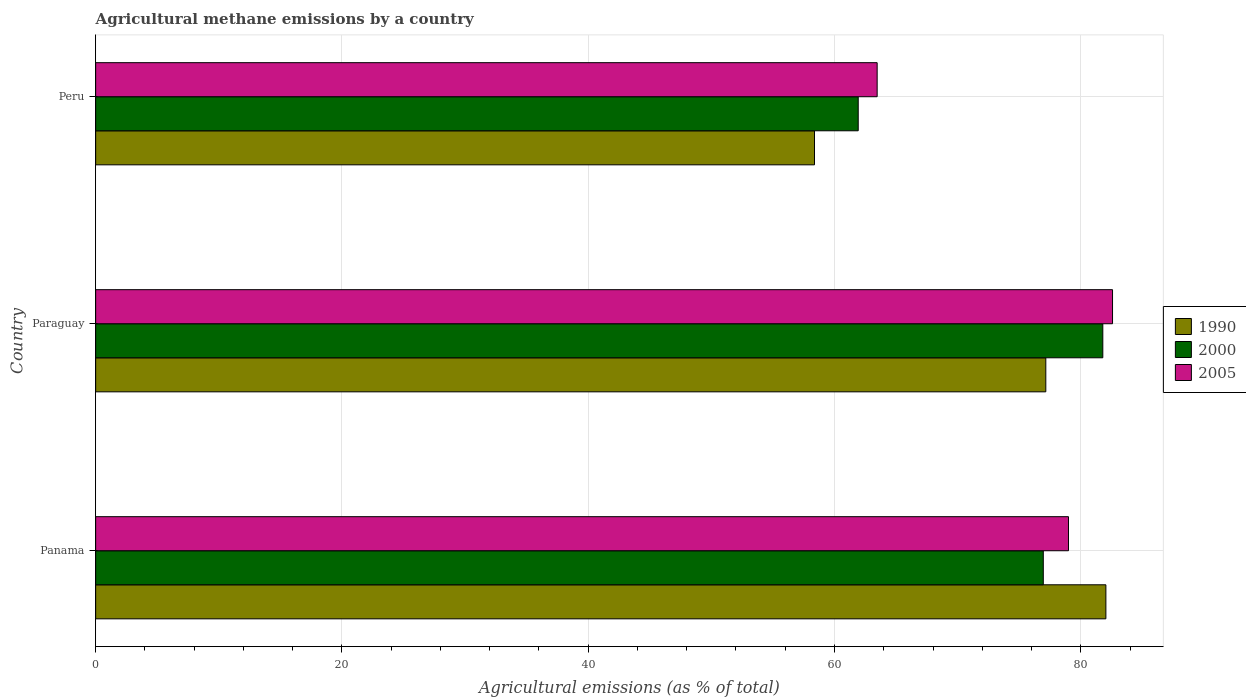How many groups of bars are there?
Ensure brevity in your answer.  3. Are the number of bars per tick equal to the number of legend labels?
Provide a short and direct response. Yes. Are the number of bars on each tick of the Y-axis equal?
Your answer should be very brief. Yes. How many bars are there on the 3rd tick from the top?
Your response must be concise. 3. How many bars are there on the 3rd tick from the bottom?
Provide a succinct answer. 3. What is the label of the 2nd group of bars from the top?
Ensure brevity in your answer.  Paraguay. What is the amount of agricultural methane emitted in 1990 in Panama?
Your answer should be compact. 82.04. Across all countries, what is the maximum amount of agricultural methane emitted in 2000?
Provide a succinct answer. 81.79. Across all countries, what is the minimum amount of agricultural methane emitted in 1990?
Give a very brief answer. 58.38. In which country was the amount of agricultural methane emitted in 2005 maximum?
Provide a short and direct response. Paraguay. In which country was the amount of agricultural methane emitted in 2000 minimum?
Offer a terse response. Peru. What is the total amount of agricultural methane emitted in 2005 in the graph?
Ensure brevity in your answer.  225.04. What is the difference between the amount of agricultural methane emitted in 1990 in Panama and that in Paraguay?
Give a very brief answer. 4.88. What is the difference between the amount of agricultural methane emitted in 1990 in Peru and the amount of agricultural methane emitted in 2005 in Paraguay?
Your answer should be very brief. -24.2. What is the average amount of agricultural methane emitted in 1990 per country?
Provide a short and direct response. 72.52. What is the difference between the amount of agricultural methane emitted in 1990 and amount of agricultural methane emitted in 2000 in Paraguay?
Provide a short and direct response. -4.63. What is the ratio of the amount of agricultural methane emitted in 1990 in Paraguay to that in Peru?
Offer a terse response. 1.32. What is the difference between the highest and the second highest amount of agricultural methane emitted in 1990?
Provide a succinct answer. 4.88. What is the difference between the highest and the lowest amount of agricultural methane emitted in 1990?
Keep it short and to the point. 23.66. What does the 1st bar from the bottom in Panama represents?
Ensure brevity in your answer.  1990. How many bars are there?
Your response must be concise. 9. Are all the bars in the graph horizontal?
Give a very brief answer. Yes. How many countries are there in the graph?
Your answer should be very brief. 3. What is the difference between two consecutive major ticks on the X-axis?
Keep it short and to the point. 20. How are the legend labels stacked?
Provide a succinct answer. Vertical. What is the title of the graph?
Keep it short and to the point. Agricultural methane emissions by a country. Does "2000" appear as one of the legend labels in the graph?
Ensure brevity in your answer.  Yes. What is the label or title of the X-axis?
Ensure brevity in your answer.  Agricultural emissions (as % of total). What is the Agricultural emissions (as % of total) in 1990 in Panama?
Your answer should be very brief. 82.04. What is the Agricultural emissions (as % of total) in 2000 in Panama?
Ensure brevity in your answer.  76.96. What is the Agricultural emissions (as % of total) of 2005 in Panama?
Your response must be concise. 79. What is the Agricultural emissions (as % of total) in 1990 in Paraguay?
Your response must be concise. 77.16. What is the Agricultural emissions (as % of total) of 2000 in Paraguay?
Provide a succinct answer. 81.79. What is the Agricultural emissions (as % of total) of 2005 in Paraguay?
Offer a very short reply. 82.58. What is the Agricultural emissions (as % of total) of 1990 in Peru?
Your answer should be compact. 58.38. What is the Agricultural emissions (as % of total) of 2000 in Peru?
Keep it short and to the point. 61.93. What is the Agricultural emissions (as % of total) of 2005 in Peru?
Keep it short and to the point. 63.46. Across all countries, what is the maximum Agricultural emissions (as % of total) in 1990?
Give a very brief answer. 82.04. Across all countries, what is the maximum Agricultural emissions (as % of total) in 2000?
Provide a succinct answer. 81.79. Across all countries, what is the maximum Agricultural emissions (as % of total) of 2005?
Provide a short and direct response. 82.58. Across all countries, what is the minimum Agricultural emissions (as % of total) in 1990?
Keep it short and to the point. 58.38. Across all countries, what is the minimum Agricultural emissions (as % of total) in 2000?
Ensure brevity in your answer.  61.93. Across all countries, what is the minimum Agricultural emissions (as % of total) of 2005?
Give a very brief answer. 63.46. What is the total Agricultural emissions (as % of total) in 1990 in the graph?
Your answer should be very brief. 217.57. What is the total Agricultural emissions (as % of total) in 2000 in the graph?
Your answer should be compact. 220.67. What is the total Agricultural emissions (as % of total) in 2005 in the graph?
Give a very brief answer. 225.04. What is the difference between the Agricultural emissions (as % of total) in 1990 in Panama and that in Paraguay?
Your response must be concise. 4.88. What is the difference between the Agricultural emissions (as % of total) in 2000 in Panama and that in Paraguay?
Provide a succinct answer. -4.83. What is the difference between the Agricultural emissions (as % of total) of 2005 in Panama and that in Paraguay?
Give a very brief answer. -3.58. What is the difference between the Agricultural emissions (as % of total) of 1990 in Panama and that in Peru?
Ensure brevity in your answer.  23.66. What is the difference between the Agricultural emissions (as % of total) in 2000 in Panama and that in Peru?
Offer a very short reply. 15.03. What is the difference between the Agricultural emissions (as % of total) in 2005 in Panama and that in Peru?
Provide a succinct answer. 15.54. What is the difference between the Agricultural emissions (as % of total) of 1990 in Paraguay and that in Peru?
Your answer should be compact. 18.78. What is the difference between the Agricultural emissions (as % of total) in 2000 in Paraguay and that in Peru?
Offer a terse response. 19.86. What is the difference between the Agricultural emissions (as % of total) in 2005 in Paraguay and that in Peru?
Your answer should be compact. 19.11. What is the difference between the Agricultural emissions (as % of total) in 1990 in Panama and the Agricultural emissions (as % of total) in 2000 in Paraguay?
Keep it short and to the point. 0.25. What is the difference between the Agricultural emissions (as % of total) in 1990 in Panama and the Agricultural emissions (as % of total) in 2005 in Paraguay?
Ensure brevity in your answer.  -0.54. What is the difference between the Agricultural emissions (as % of total) of 2000 in Panama and the Agricultural emissions (as % of total) of 2005 in Paraguay?
Your answer should be very brief. -5.62. What is the difference between the Agricultural emissions (as % of total) of 1990 in Panama and the Agricultural emissions (as % of total) of 2000 in Peru?
Keep it short and to the point. 20.11. What is the difference between the Agricultural emissions (as % of total) of 1990 in Panama and the Agricultural emissions (as % of total) of 2005 in Peru?
Offer a very short reply. 18.58. What is the difference between the Agricultural emissions (as % of total) of 2000 in Panama and the Agricultural emissions (as % of total) of 2005 in Peru?
Make the answer very short. 13.49. What is the difference between the Agricultural emissions (as % of total) of 1990 in Paraguay and the Agricultural emissions (as % of total) of 2000 in Peru?
Offer a terse response. 15.23. What is the difference between the Agricultural emissions (as % of total) in 1990 in Paraguay and the Agricultural emissions (as % of total) in 2005 in Peru?
Give a very brief answer. 13.7. What is the difference between the Agricultural emissions (as % of total) in 2000 in Paraguay and the Agricultural emissions (as % of total) in 2005 in Peru?
Keep it short and to the point. 18.33. What is the average Agricultural emissions (as % of total) of 1990 per country?
Give a very brief answer. 72.52. What is the average Agricultural emissions (as % of total) in 2000 per country?
Your response must be concise. 73.56. What is the average Agricultural emissions (as % of total) of 2005 per country?
Your answer should be compact. 75.01. What is the difference between the Agricultural emissions (as % of total) in 1990 and Agricultural emissions (as % of total) in 2000 in Panama?
Your answer should be compact. 5.08. What is the difference between the Agricultural emissions (as % of total) in 1990 and Agricultural emissions (as % of total) in 2005 in Panama?
Offer a terse response. 3.04. What is the difference between the Agricultural emissions (as % of total) of 2000 and Agricultural emissions (as % of total) of 2005 in Panama?
Offer a very short reply. -2.04. What is the difference between the Agricultural emissions (as % of total) in 1990 and Agricultural emissions (as % of total) in 2000 in Paraguay?
Your answer should be very brief. -4.63. What is the difference between the Agricultural emissions (as % of total) of 1990 and Agricultural emissions (as % of total) of 2005 in Paraguay?
Offer a very short reply. -5.42. What is the difference between the Agricultural emissions (as % of total) in 2000 and Agricultural emissions (as % of total) in 2005 in Paraguay?
Ensure brevity in your answer.  -0.79. What is the difference between the Agricultural emissions (as % of total) in 1990 and Agricultural emissions (as % of total) in 2000 in Peru?
Provide a succinct answer. -3.55. What is the difference between the Agricultural emissions (as % of total) in 1990 and Agricultural emissions (as % of total) in 2005 in Peru?
Make the answer very short. -5.09. What is the difference between the Agricultural emissions (as % of total) in 2000 and Agricultural emissions (as % of total) in 2005 in Peru?
Offer a very short reply. -1.54. What is the ratio of the Agricultural emissions (as % of total) in 1990 in Panama to that in Paraguay?
Keep it short and to the point. 1.06. What is the ratio of the Agricultural emissions (as % of total) in 2000 in Panama to that in Paraguay?
Make the answer very short. 0.94. What is the ratio of the Agricultural emissions (as % of total) of 2005 in Panama to that in Paraguay?
Provide a succinct answer. 0.96. What is the ratio of the Agricultural emissions (as % of total) of 1990 in Panama to that in Peru?
Offer a terse response. 1.41. What is the ratio of the Agricultural emissions (as % of total) of 2000 in Panama to that in Peru?
Keep it short and to the point. 1.24. What is the ratio of the Agricultural emissions (as % of total) in 2005 in Panama to that in Peru?
Provide a succinct answer. 1.24. What is the ratio of the Agricultural emissions (as % of total) in 1990 in Paraguay to that in Peru?
Offer a very short reply. 1.32. What is the ratio of the Agricultural emissions (as % of total) in 2000 in Paraguay to that in Peru?
Ensure brevity in your answer.  1.32. What is the ratio of the Agricultural emissions (as % of total) in 2005 in Paraguay to that in Peru?
Offer a very short reply. 1.3. What is the difference between the highest and the second highest Agricultural emissions (as % of total) in 1990?
Provide a short and direct response. 4.88. What is the difference between the highest and the second highest Agricultural emissions (as % of total) in 2000?
Your answer should be very brief. 4.83. What is the difference between the highest and the second highest Agricultural emissions (as % of total) in 2005?
Offer a very short reply. 3.58. What is the difference between the highest and the lowest Agricultural emissions (as % of total) in 1990?
Your answer should be very brief. 23.66. What is the difference between the highest and the lowest Agricultural emissions (as % of total) of 2000?
Your answer should be very brief. 19.86. What is the difference between the highest and the lowest Agricultural emissions (as % of total) in 2005?
Keep it short and to the point. 19.11. 